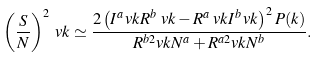<formula> <loc_0><loc_0><loc_500><loc_500>\left ( \frac { S } { N } \right ) ^ { 2 } _ { \ } v k \simeq \frac { 2 \left ( I ^ { a } _ { \ } v k R ^ { b } _ { \ } v k - R ^ { a } _ { \ } v k I ^ { b } _ { \ } v k \right ) ^ { 2 } P ( k ) } { R ^ { b 2 } _ { \ } v k N ^ { a } + R ^ { a 2 } _ { \ } v k N ^ { b } } .</formula> 